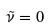<formula> <loc_0><loc_0><loc_500><loc_500>\tilde { \nu } = 0</formula> 